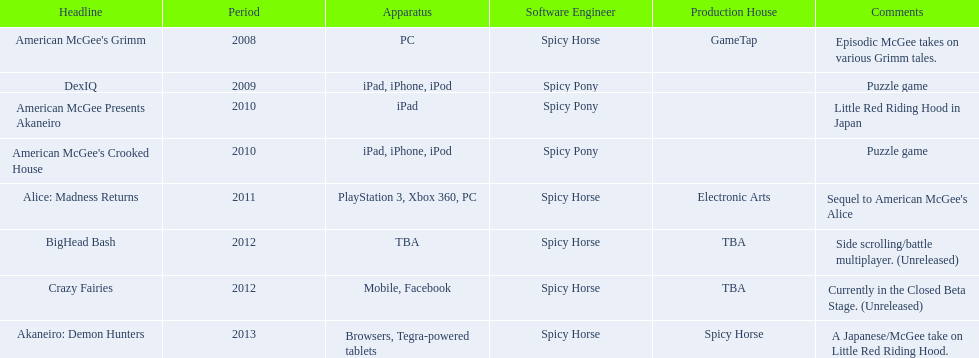What are all of the titles? American McGee's Grimm, DexIQ, American McGee Presents Akaneiro, American McGee's Crooked House, Alice: Madness Returns, BigHead Bash, Crazy Fairies, Akaneiro: Demon Hunters. Who published each title? GameTap, , , , Electronic Arts, TBA, TBA, Spicy Horse. Which game was published by electronics arts? Alice: Madness Returns. 